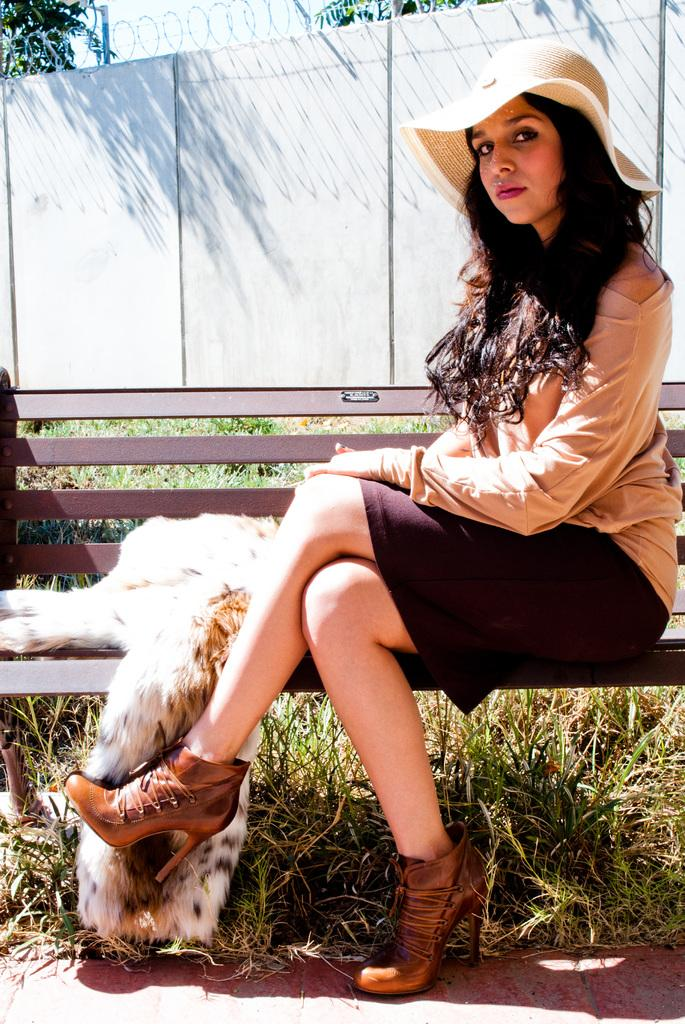Who is present in the image? There is a woman in the image. What is the woman wearing on her head? The woman is wearing a hat. Where is the woman sitting? The woman is sitting on a bench. What type of clothing is beside the woman? There is a woolen coat beside the woman. What type of natural environment is visible in the image? There is grass visible in the image, as well as trees. What is the background of the image? The background includes a fence and the sky. What date is marked on the calendar in the image? There is no calendar present in the image, so it is not possible to determine the date. 